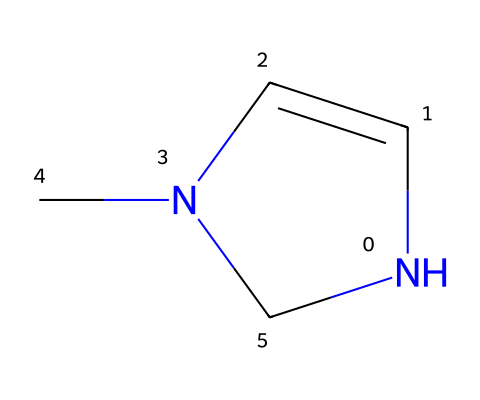What is the total number of carbon atoms in this structure? To determine the total number of carbon atoms, we can visually trace the carbon centers in the SMILES representation. The SMILES indicates three distinct carbon atoms attached to a nitrogen atom in a ring structure.
Answer: three How many nitrogen atoms are present in this chemical? By referencing the SMILES and examining its structure, we can identify that there’s one nitrogen atom present in the cyclic part of the molecule.
Answer: one What type of ring structure is formed in this compound? The presence of carbon and nitrogen in the ring, along with the number of atoms indicates that it's a five-membered ring. This is typical of certain heterocycles.
Answer: five-membered ring What is the role of the nitrogen atom in this carbene structure? The nitrogen atom contributes to the stability and reactivity of the carbene, potentially allowing it to participate in reactions involving electron pair donation or coordination.
Answer: reactivity Can this compound act as a ligand in coordination chemistry? The structure of the compound suggests it contains a lone pair of electrons from the nitrogen, enabling it to act as a ligand to coordinate with metal centers in catalysts.
Answer: yes What is a potential application of this carbene in eco-friendly dye production? The unique structural properties of this carbene may allow it to facilitate reactions that produce dyes from sustainable resources, aligning with cultural preservation efforts.
Answer: dye production 